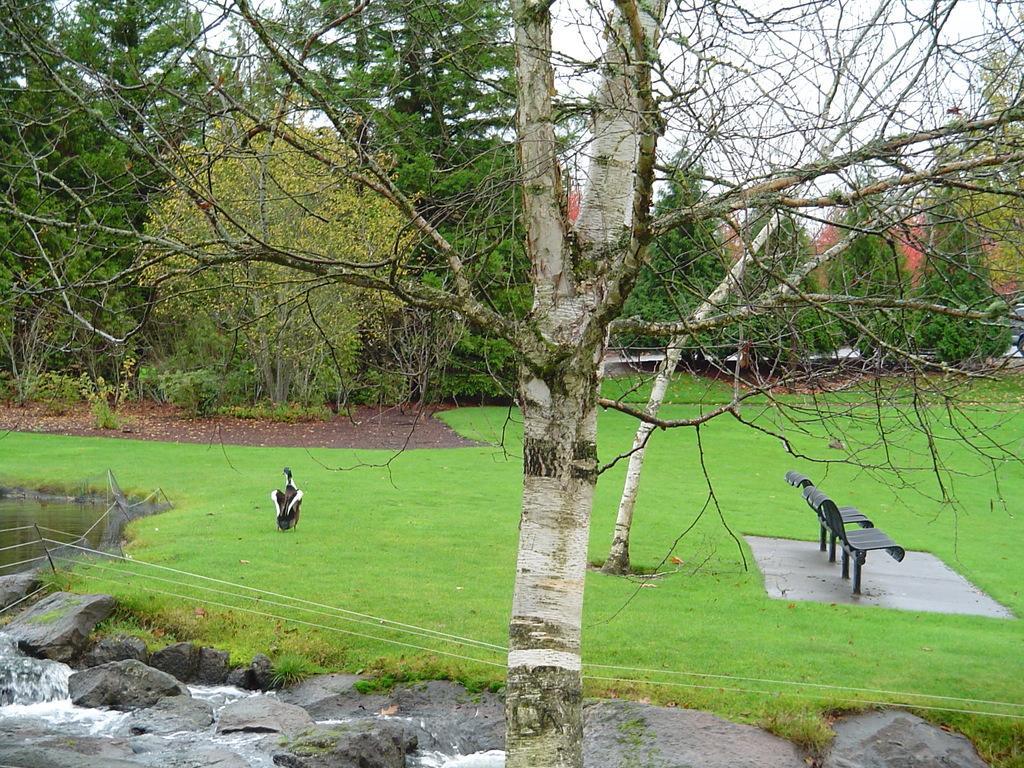In one or two sentences, can you explain what this image depicts? In this image I can see an open grass ground and on it I can see a bird and two benches. I can also see number of trees, the sky in the background and on the left side I can see wires and water. 